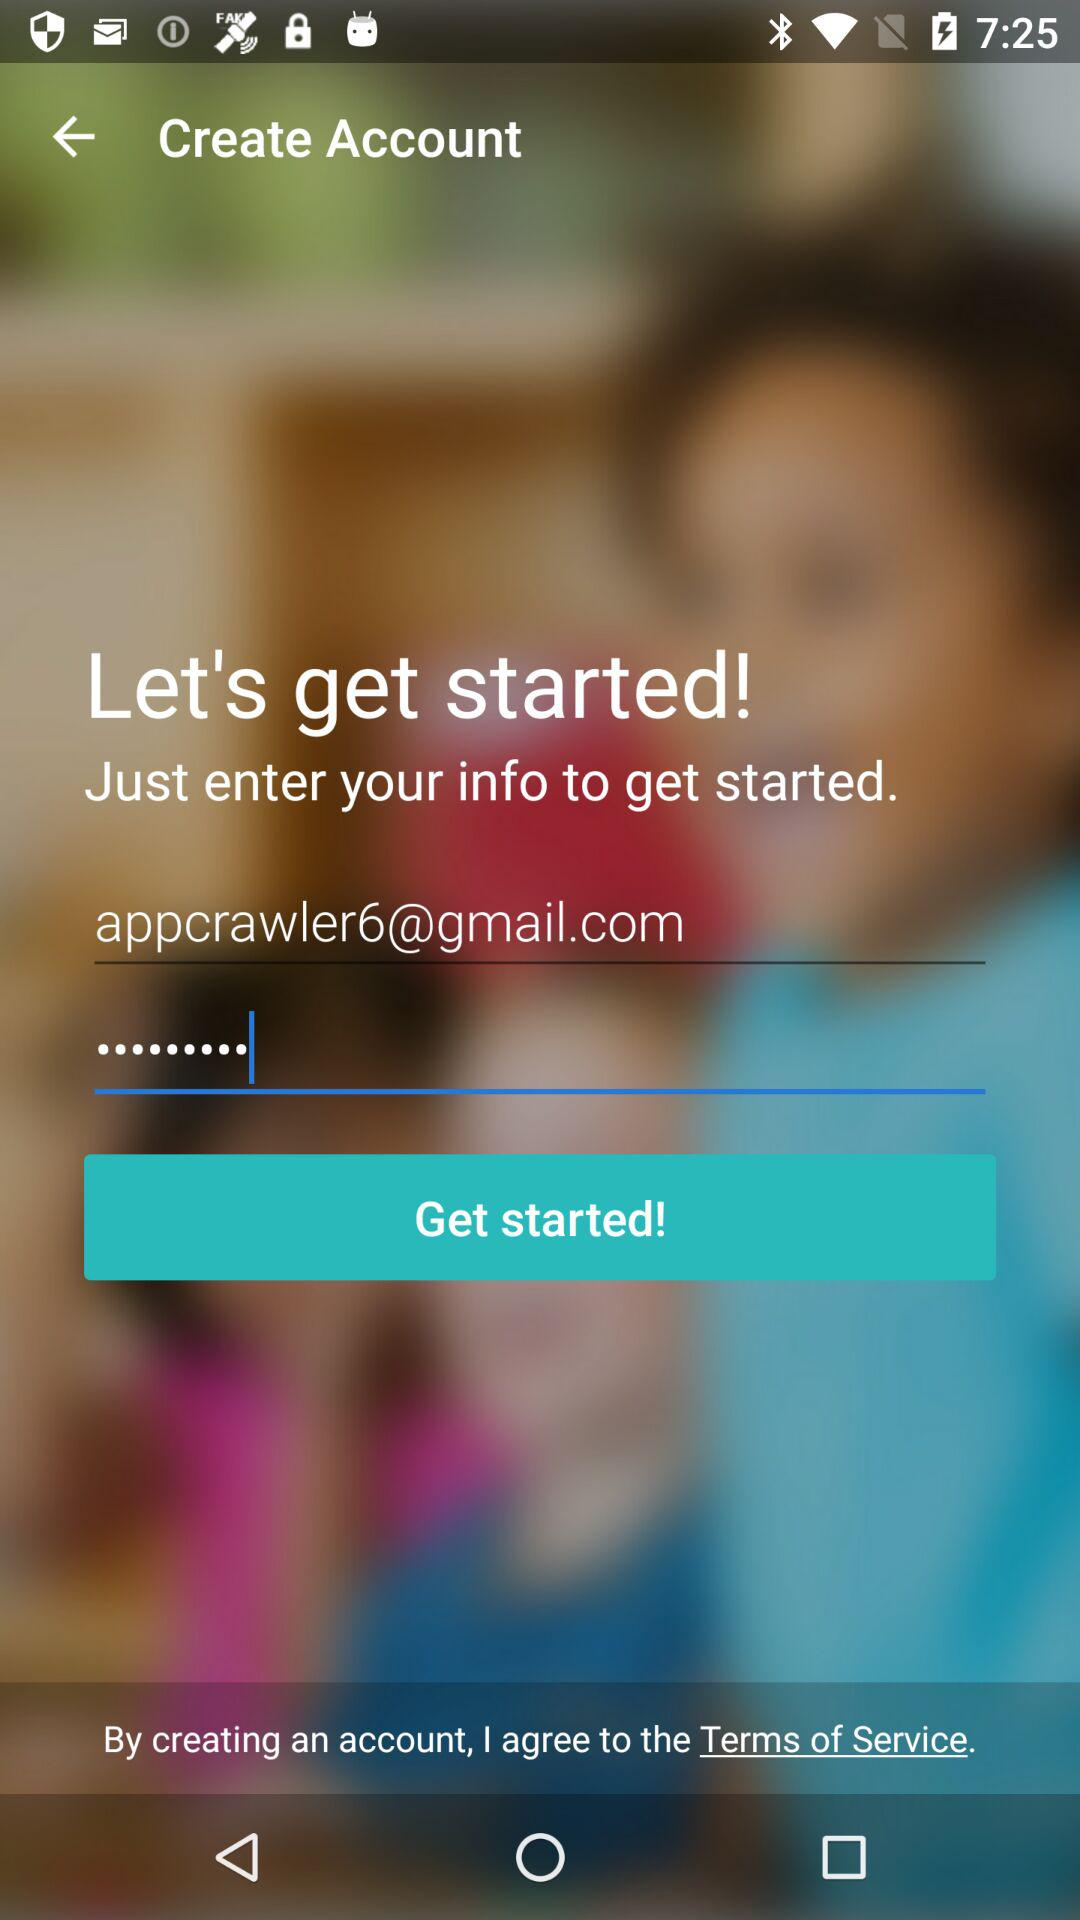What is the user name? The user name is appcrawler6@gmail.com. 